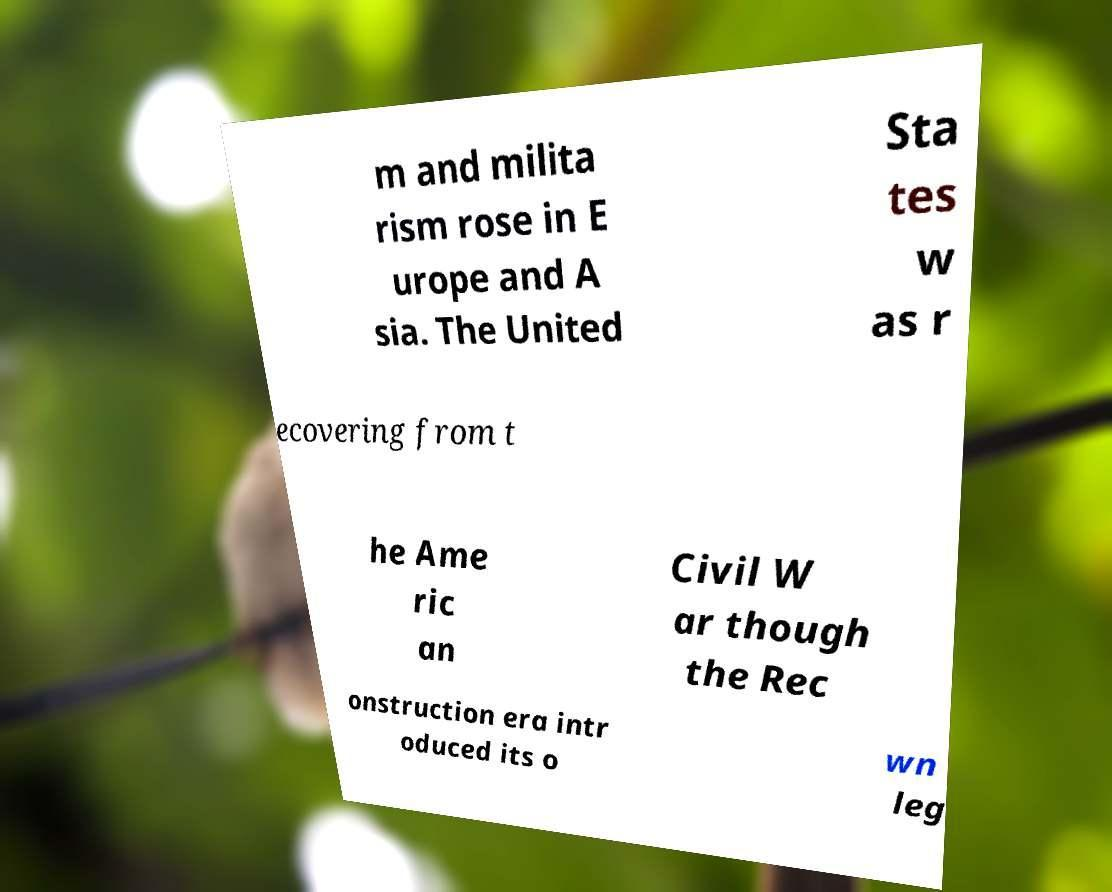I need the written content from this picture converted into text. Can you do that? m and milita rism rose in E urope and A sia. The United Sta tes w as r ecovering from t he Ame ric an Civil W ar though the Rec onstruction era intr oduced its o wn leg 